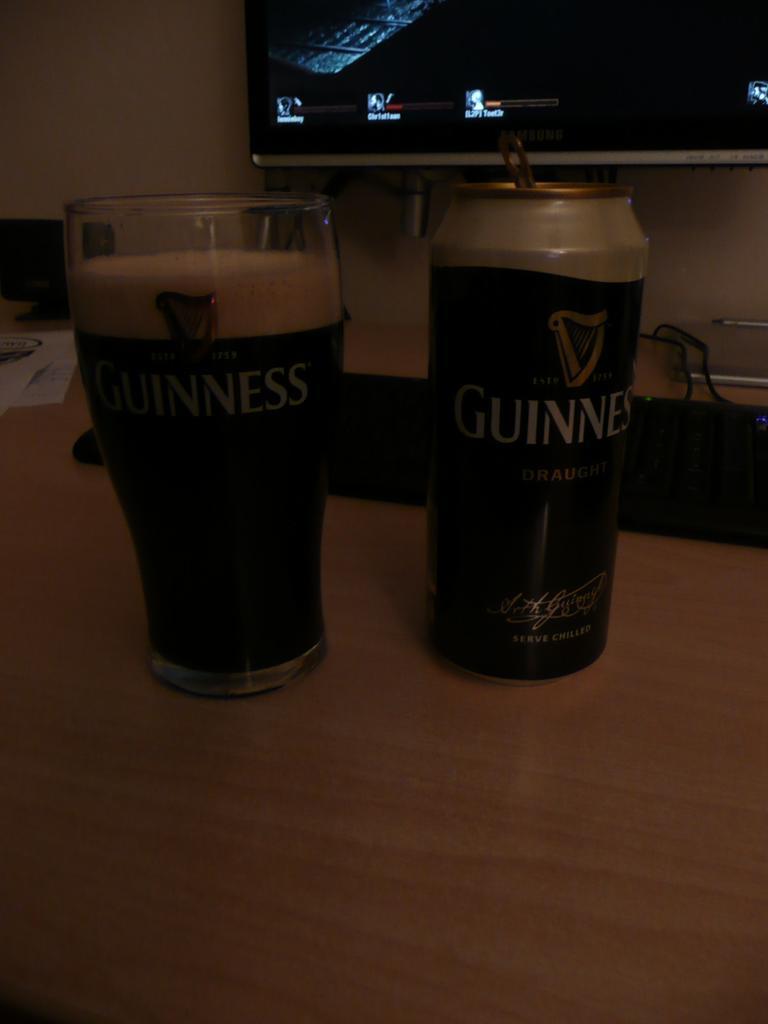How would you summarize this image in a sentence or two? In this picture we can see a table, there is a glass of drink and a tin present on the table, in the background we can see a wall and a monitor, on the right side it looks like a laptop. 